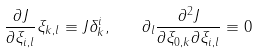<formula> <loc_0><loc_0><loc_500><loc_500>\frac { \partial J } { \partial \xi _ { i , l } } \xi _ { k , l } \equiv J \delta _ { k } ^ { i } , \quad \partial _ { l } \frac { \partial ^ { 2 } J } { \partial \xi _ { 0 , k } \partial \xi _ { i , l } } \equiv 0</formula> 